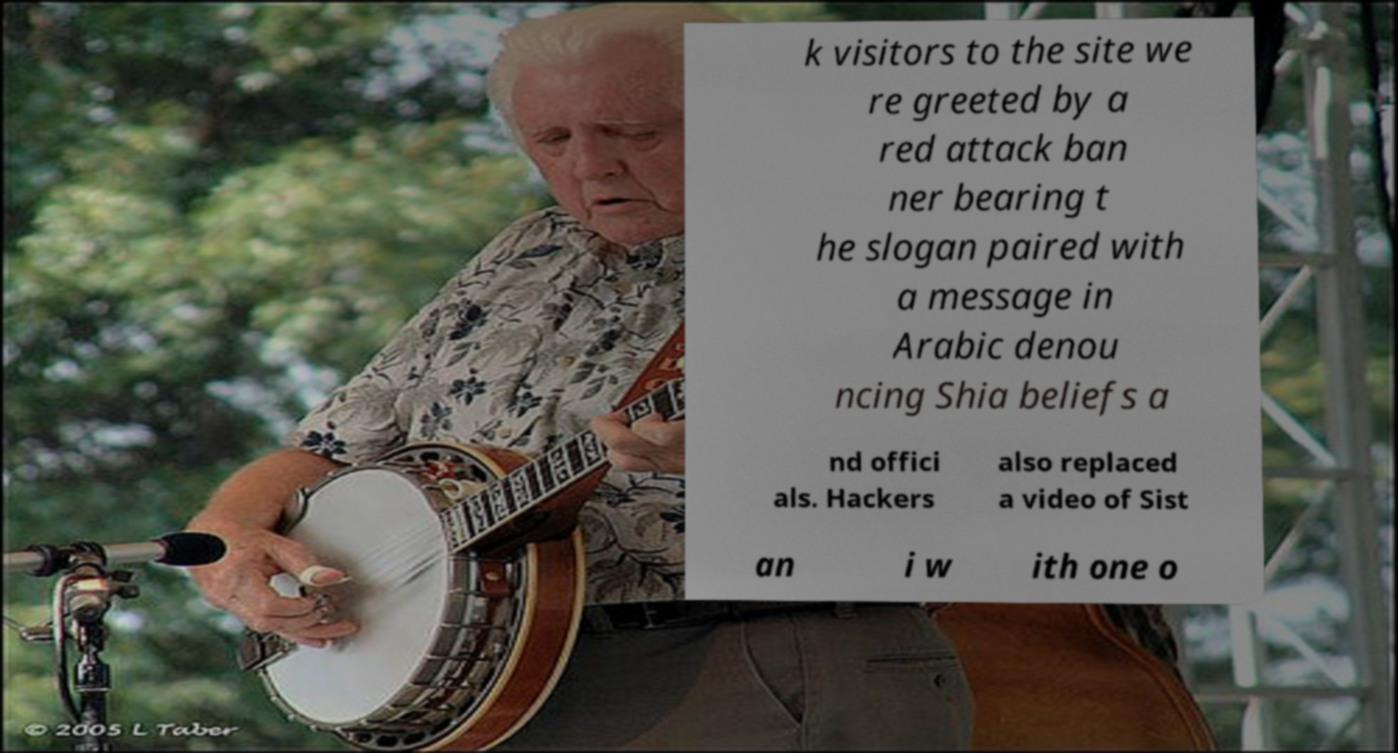I need the written content from this picture converted into text. Can you do that? k visitors to the site we re greeted by a red attack ban ner bearing t he slogan paired with a message in Arabic denou ncing Shia beliefs a nd offici als. Hackers also replaced a video of Sist an i w ith one o 